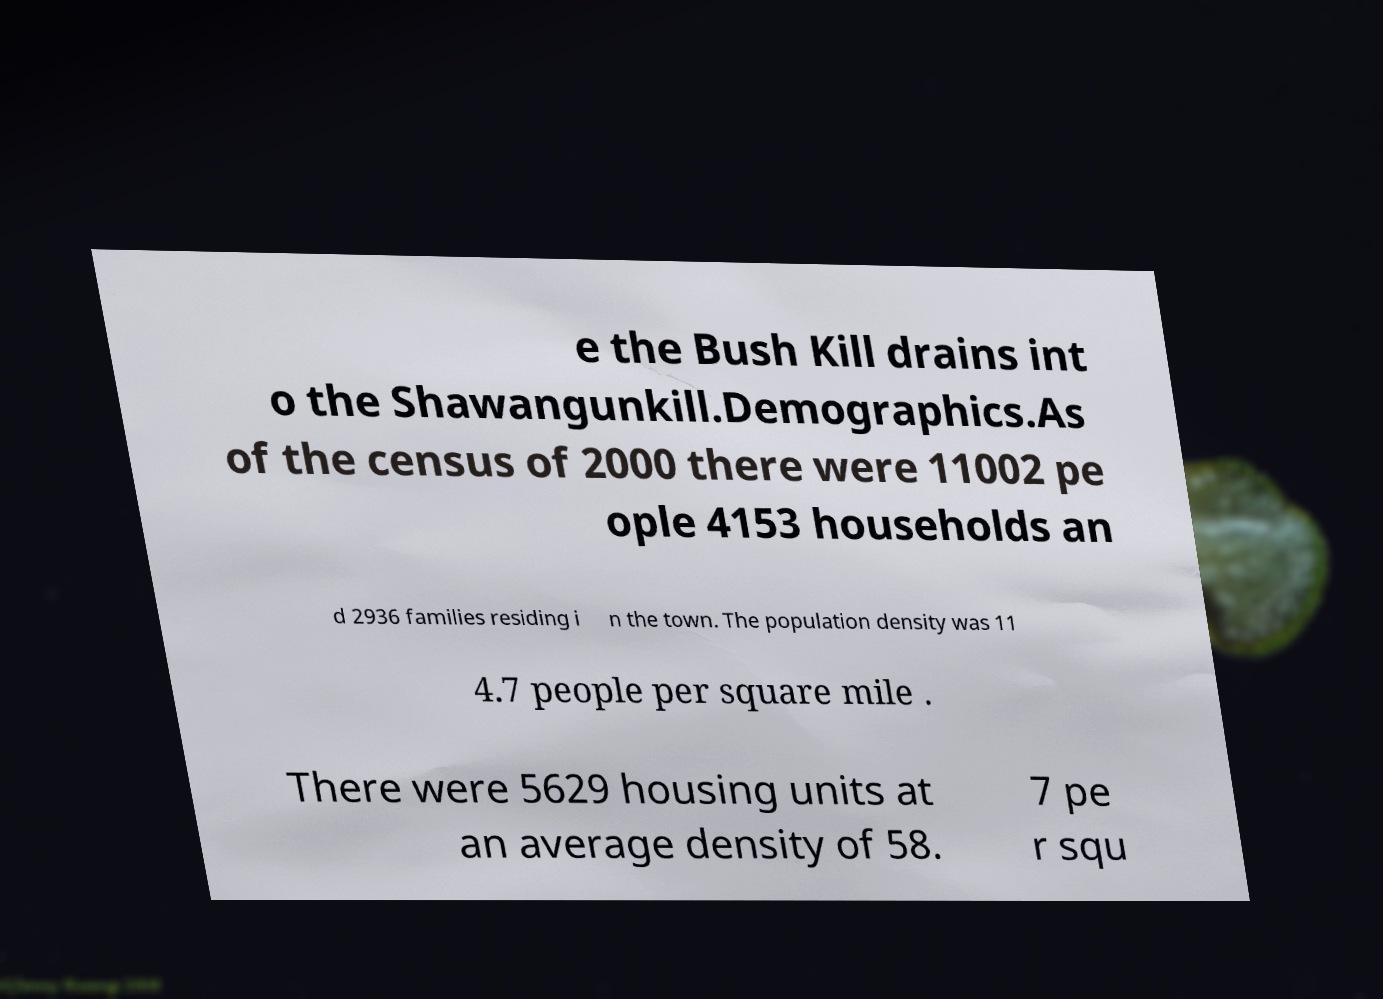Please identify and transcribe the text found in this image. e the Bush Kill drains int o the Shawangunkill.Demographics.As of the census of 2000 there were 11002 pe ople 4153 households an d 2936 families residing i n the town. The population density was 11 4.7 people per square mile . There were 5629 housing units at an average density of 58. 7 pe r squ 